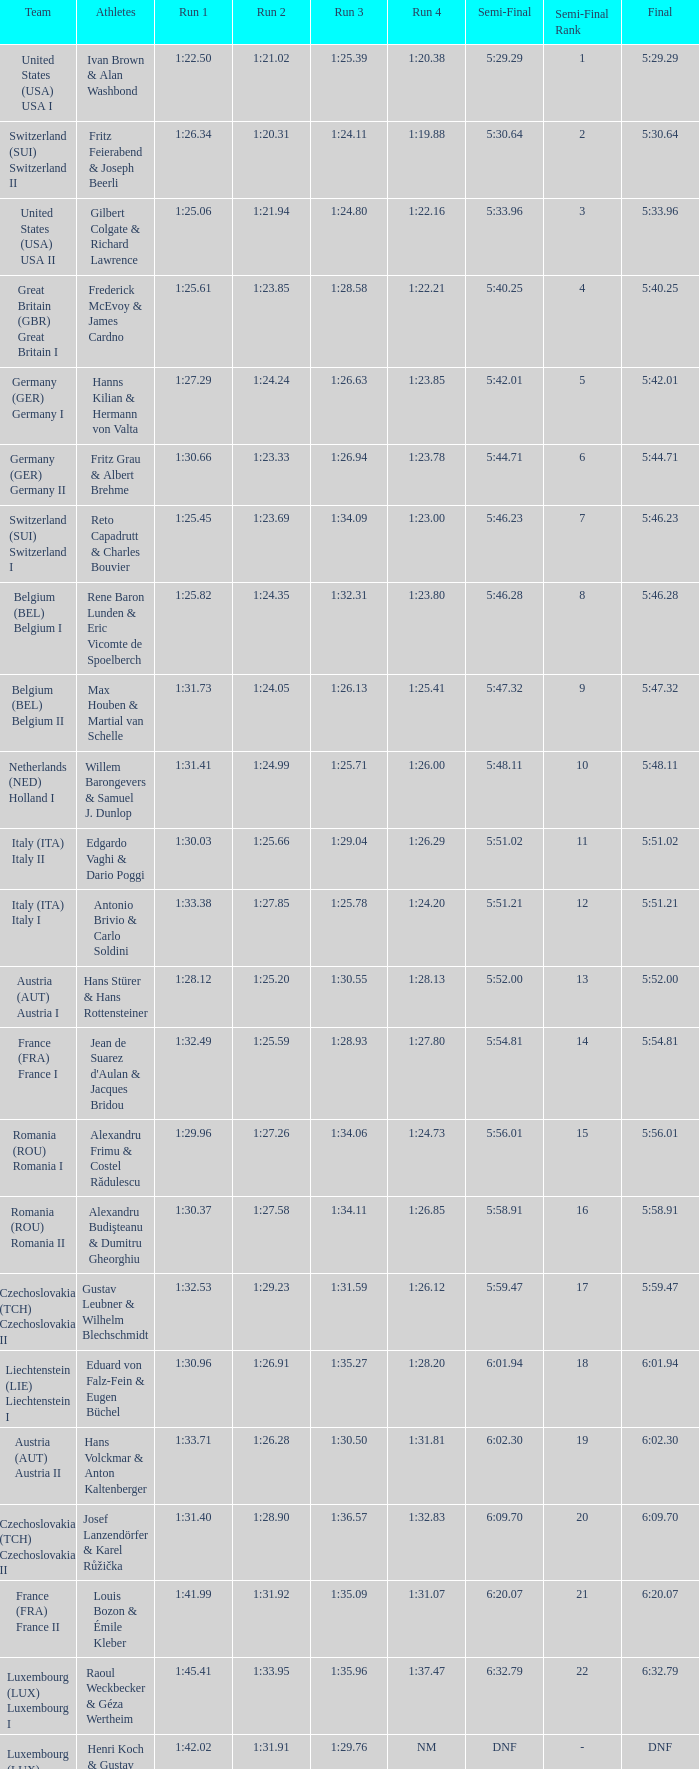Which Final has a Run 2 of 1:27.58? 5:58.91. 